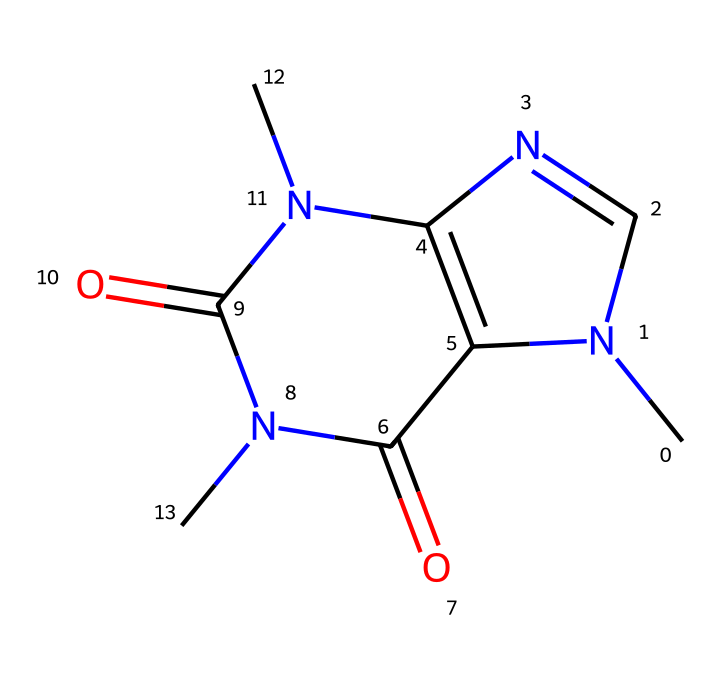What is the molecular formula of caffeine? By analyzing the SMILES representation, we can count the number of each type of atom present. For caffeine, there are 8 carbons (C), 10 hydrogens (H), 4 nitrogens (N), and 2 oxygens (O). Thus, the molecular formula is C8H10N4O2.
Answer: C8H10N4O2 How many nitrogen atoms are in the caffeine structure? By examining the SMILES representation, we identify that there are four nitrogen atoms (N) present in the structure.
Answer: 4 What type of compound is caffeine classified as? Caffeine contains nitrogen atoms and has pharmacological effects; thus, it is classified as an alkaloid.
Answer: alkaloid What is the primary functional group in caffeine? Caffeine has two carbonyl groups (C=O) which are characteristic of amides and contribute to its medicinal properties. Identifying these groups from the structure tells us that these are present, making it an important functional feature.
Answer: carbonyl How might the structure of caffeine affect its stimulant properties? The arrangement of carbon, nitrogen, and oxygen atoms allows caffeine to interact effectively with adenosine receptors in the brain, blocking their effects. This structural configuration is key to its role as a stimulant.
Answer: adenosine receptors What type of bonds are predominantly found in the caffeine molecule? Analyzing the chemical structure, there are both single (C-N, C-C) and double bonds (C=O) present in caffeine. However, single bonds are more numerous. Thus, the main types are single and double bonds.
Answer: single and double bonds 